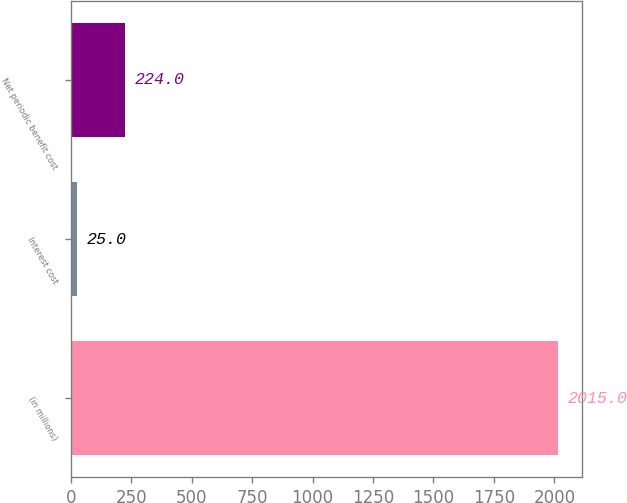Convert chart. <chart><loc_0><loc_0><loc_500><loc_500><bar_chart><fcel>(in millions)<fcel>Interest cost<fcel>Net periodic benefit cost<nl><fcel>2015<fcel>25<fcel>224<nl></chart> 